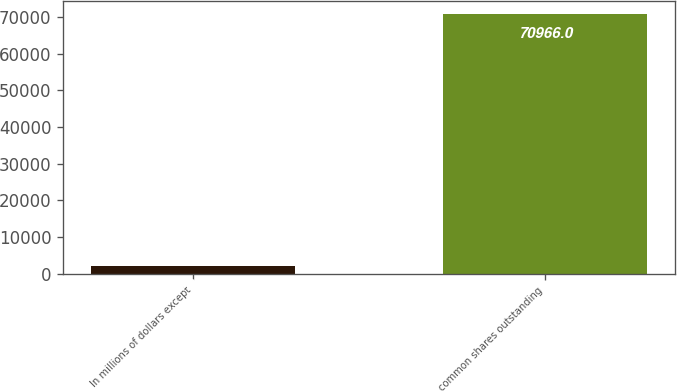Convert chart to OTSL. <chart><loc_0><loc_0><loc_500><loc_500><bar_chart><fcel>In millions of dollars except<fcel>common shares outstanding<nl><fcel>2008<fcel>70966<nl></chart> 